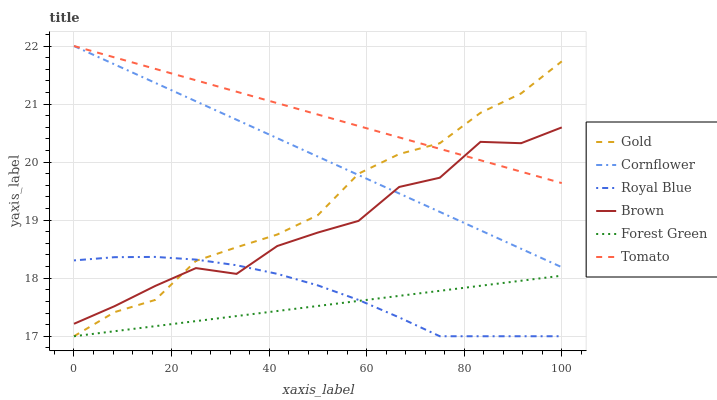Does Forest Green have the minimum area under the curve?
Answer yes or no. Yes. Does Tomato have the maximum area under the curve?
Answer yes or no. Yes. Does Cornflower have the minimum area under the curve?
Answer yes or no. No. Does Cornflower have the maximum area under the curve?
Answer yes or no. No. Is Cornflower the smoothest?
Answer yes or no. Yes. Is Brown the roughest?
Answer yes or no. Yes. Is Gold the smoothest?
Answer yes or no. No. Is Gold the roughest?
Answer yes or no. No. Does Gold have the lowest value?
Answer yes or no. Yes. Does Cornflower have the lowest value?
Answer yes or no. No. Does Cornflower have the highest value?
Answer yes or no. Yes. Does Gold have the highest value?
Answer yes or no. No. Is Royal Blue less than Cornflower?
Answer yes or no. Yes. Is Brown greater than Forest Green?
Answer yes or no. Yes. Does Brown intersect Cornflower?
Answer yes or no. Yes. Is Brown less than Cornflower?
Answer yes or no. No. Is Brown greater than Cornflower?
Answer yes or no. No. Does Royal Blue intersect Cornflower?
Answer yes or no. No. 